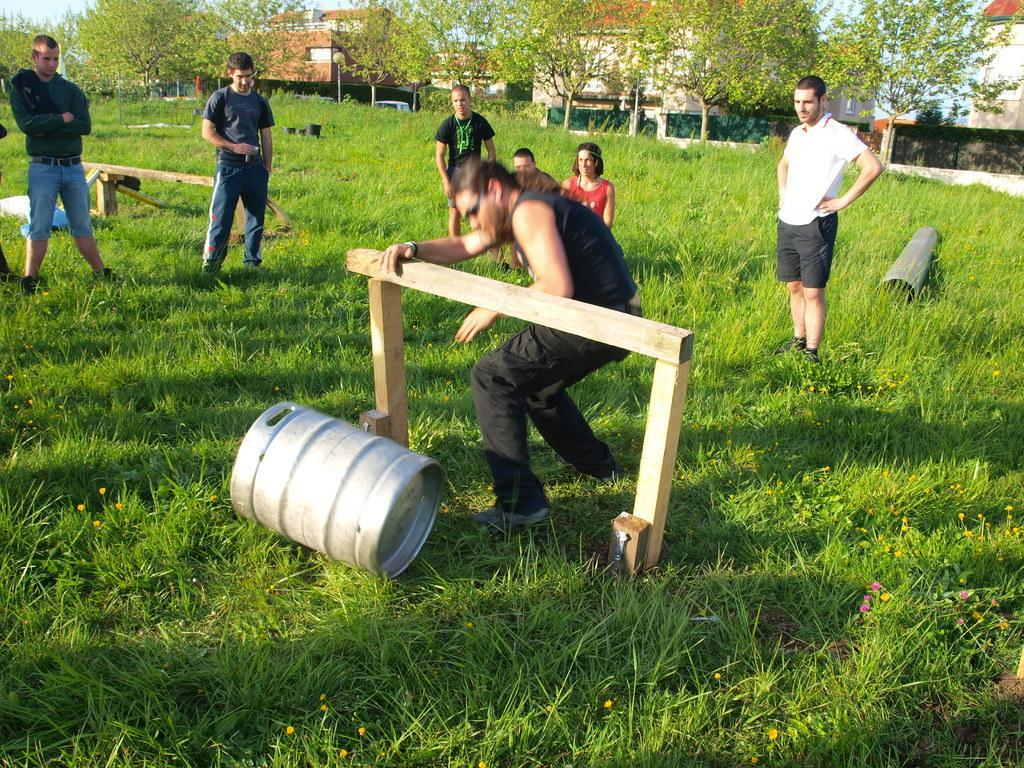In one or two sentences, can you explain what this image depicts? In this image I can see a person wearing black dress is standing and holding a wooden log in his hand and I can see a metal container on the ground. In the background I can see few other persons standing on the ground, some grass, a pipe on the ground, few trees, few buildings and the sky. 